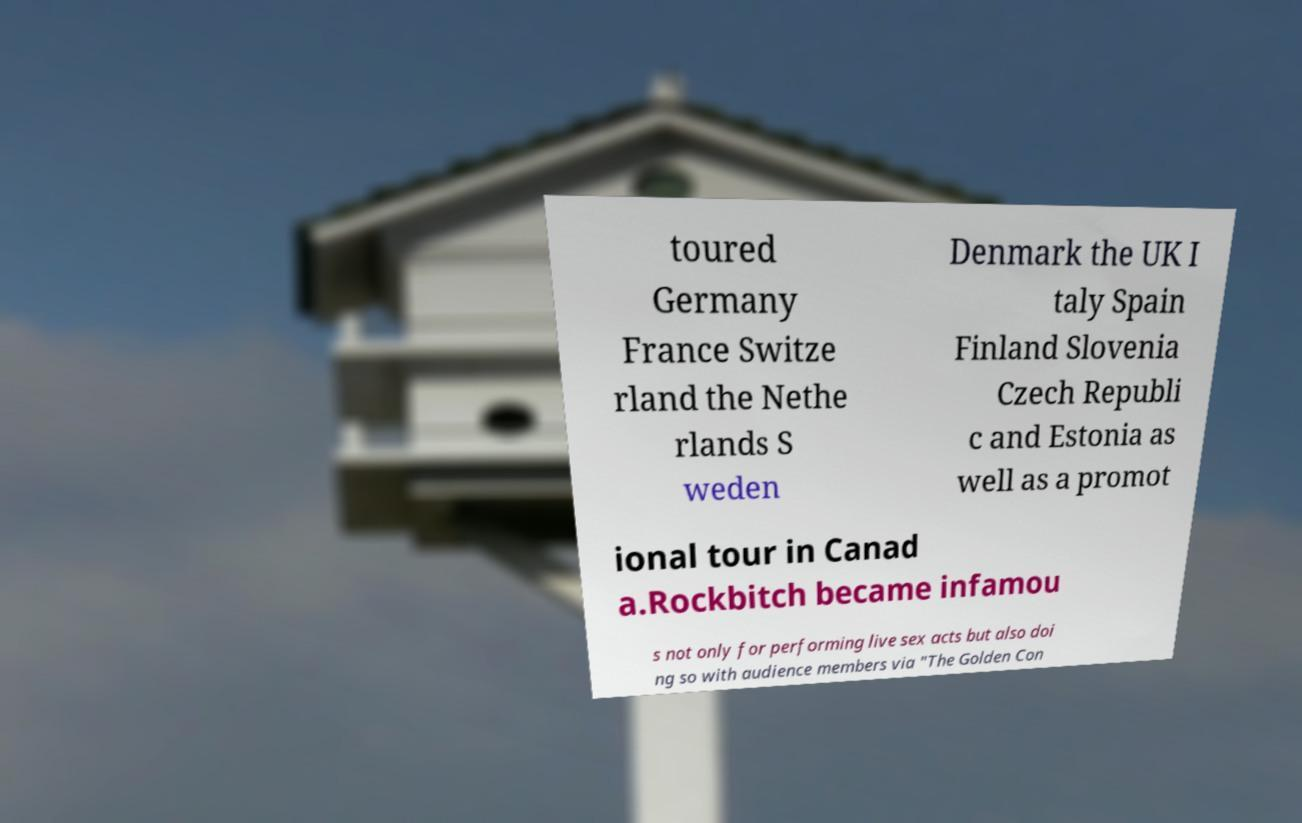Could you extract and type out the text from this image? toured Germany France Switze rland the Nethe rlands S weden Denmark the UK I taly Spain Finland Slovenia Czech Republi c and Estonia as well as a promot ional tour in Canad a.Rockbitch became infamou s not only for performing live sex acts but also doi ng so with audience members via "The Golden Con 